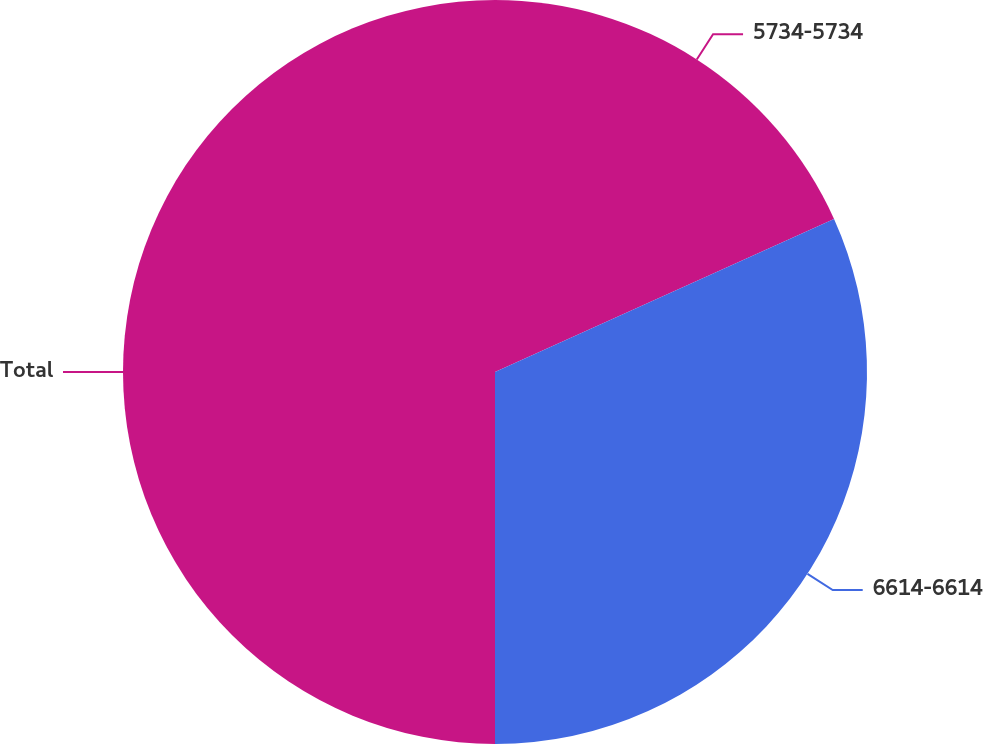Convert chart to OTSL. <chart><loc_0><loc_0><loc_500><loc_500><pie_chart><fcel>5734-5734<fcel>6614-6614<fcel>Total<nl><fcel>18.25%<fcel>31.75%<fcel>50.0%<nl></chart> 